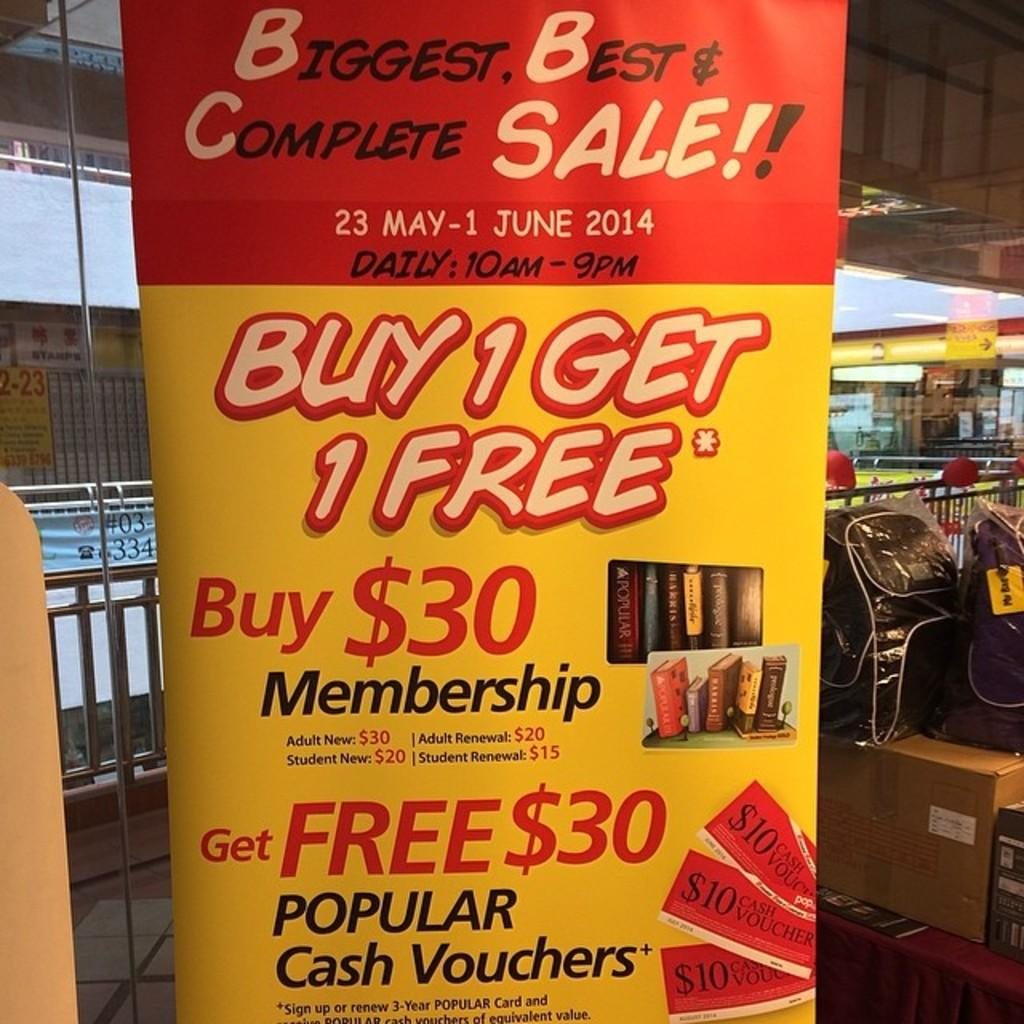What is the main subject of the image? The main subject of the image is an advertisement banner. What type of advertisement is on the banner? The banner is for a membership. What special offer is mentioned on the banner? The banner says "buy one get one free." What religious symbol is present on the banner? There is no religious symbol present on the banner; it is an advertisement for a membership with a "buy one get one free" offer. 